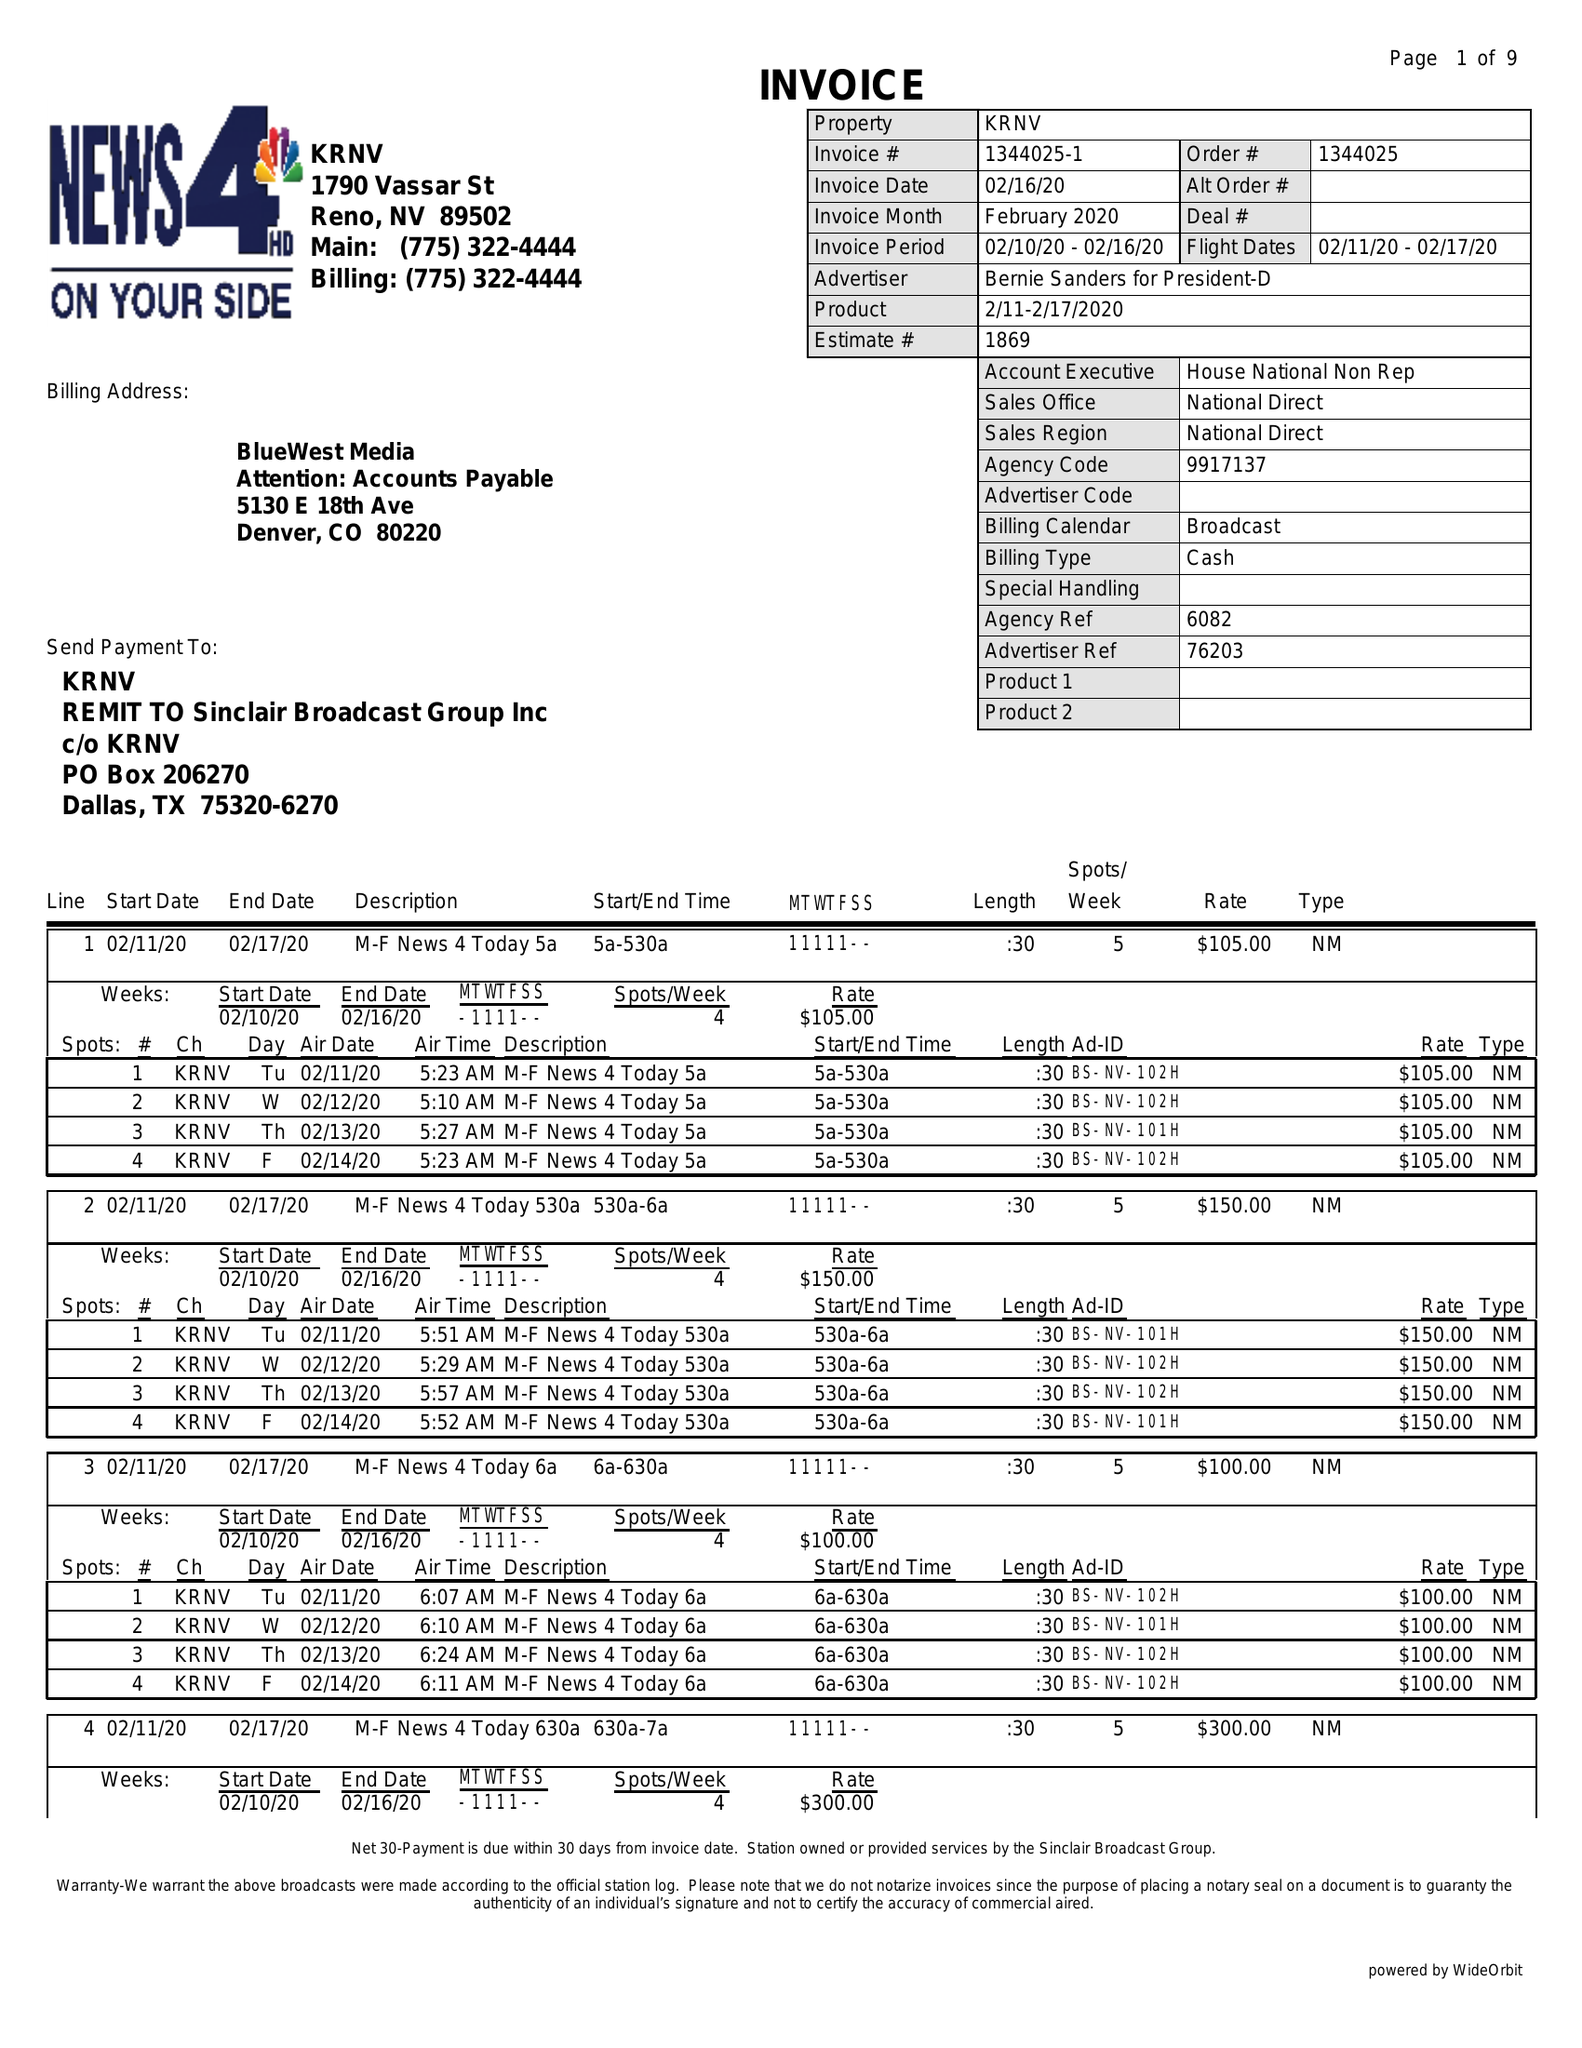What is the value for the flight_to?
Answer the question using a single word or phrase. 02/17/20 